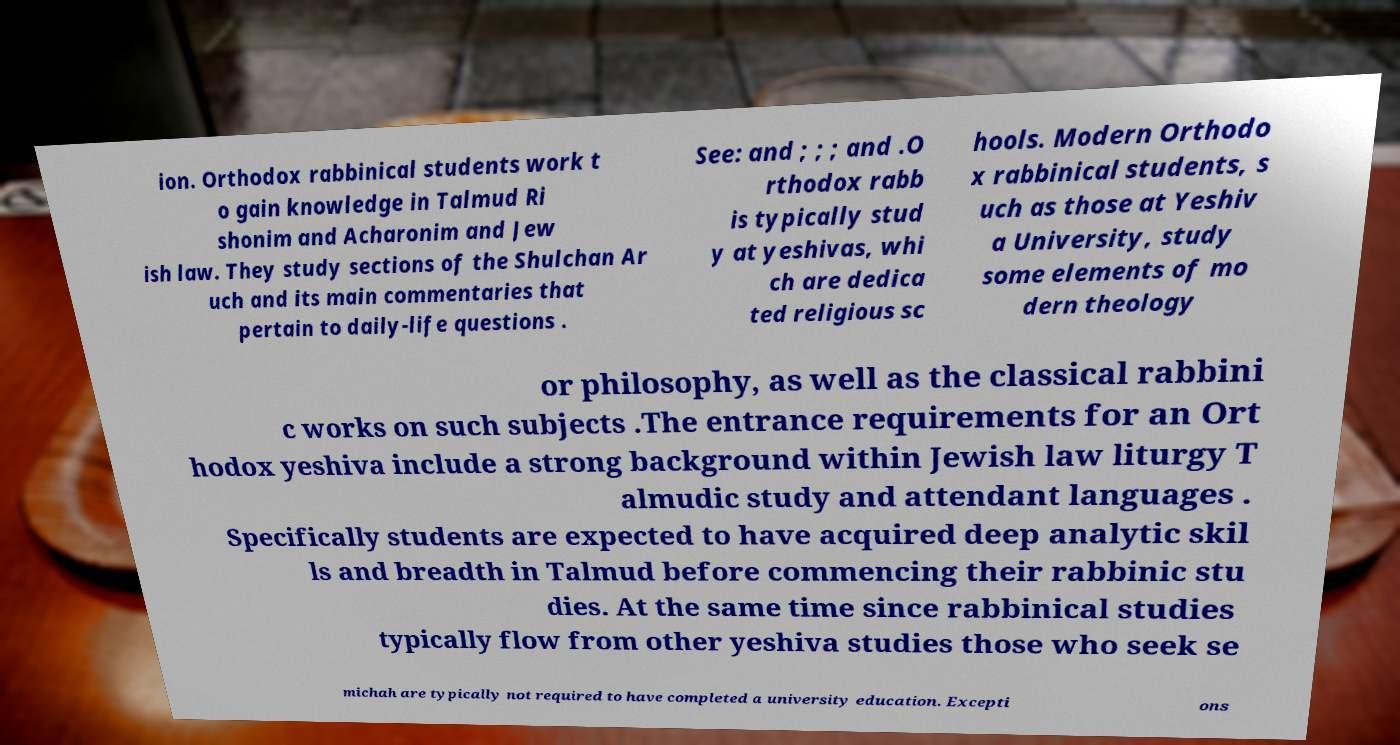There's text embedded in this image that I need extracted. Can you transcribe it verbatim? ion. Orthodox rabbinical students work t o gain knowledge in Talmud Ri shonim and Acharonim and Jew ish law. They study sections of the Shulchan Ar uch and its main commentaries that pertain to daily-life questions . See: and ; ; ; and .O rthodox rabb is typically stud y at yeshivas, whi ch are dedica ted religious sc hools. Modern Orthodo x rabbinical students, s uch as those at Yeshiv a University, study some elements of mo dern theology or philosophy, as well as the classical rabbini c works on such subjects .The entrance requirements for an Ort hodox yeshiva include a strong background within Jewish law liturgy T almudic study and attendant languages . Specifically students are expected to have acquired deep analytic skil ls and breadth in Talmud before commencing their rabbinic stu dies. At the same time since rabbinical studies typically flow from other yeshiva studies those who seek se michah are typically not required to have completed a university education. Excepti ons 